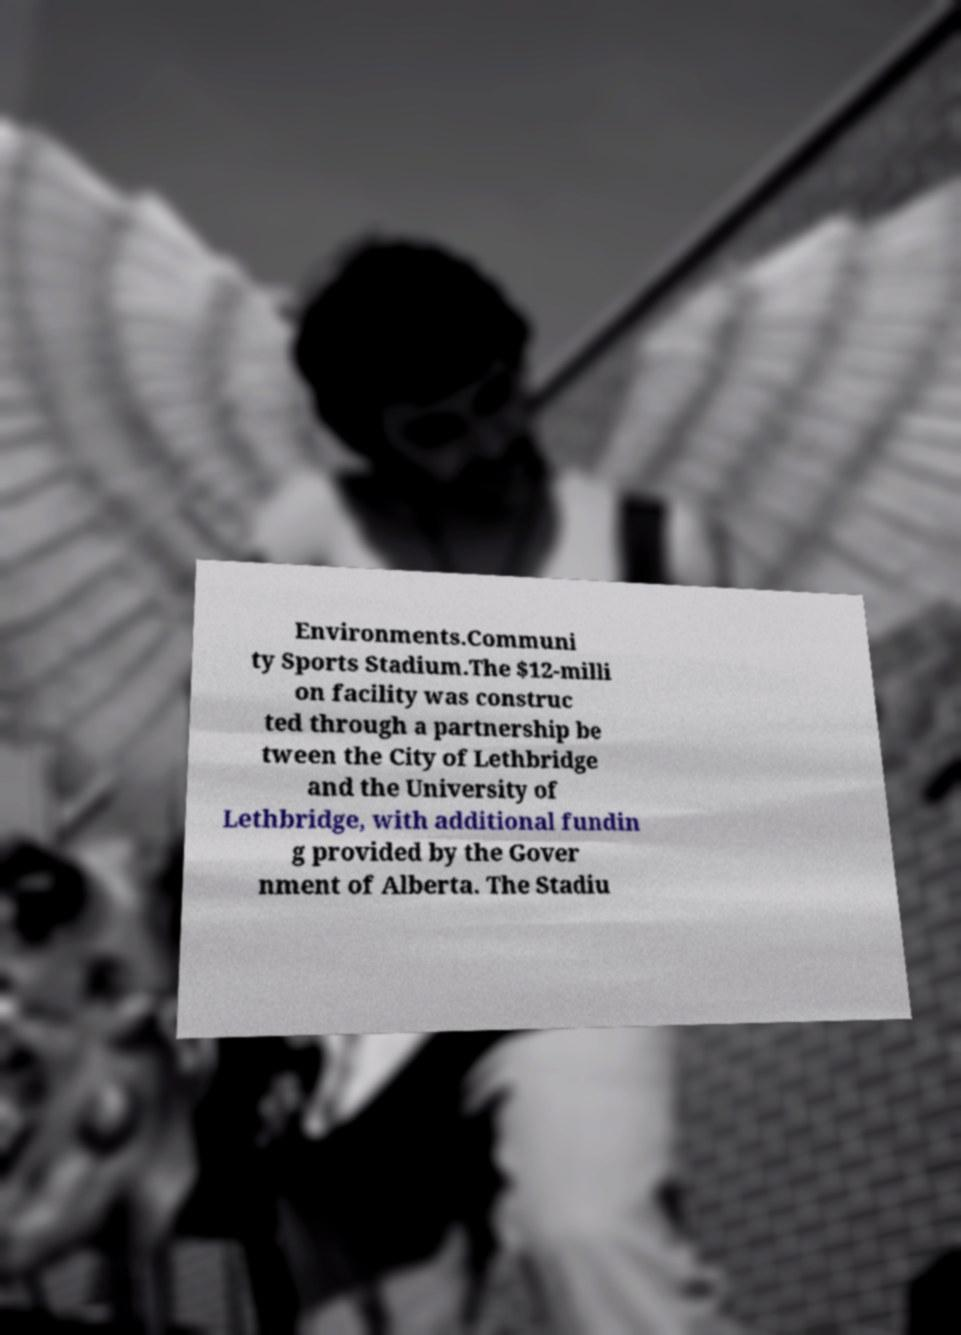Could you assist in decoding the text presented in this image and type it out clearly? Environments.Communi ty Sports Stadium.The $12-milli on facility was construc ted through a partnership be tween the City of Lethbridge and the University of Lethbridge, with additional fundin g provided by the Gover nment of Alberta. The Stadiu 